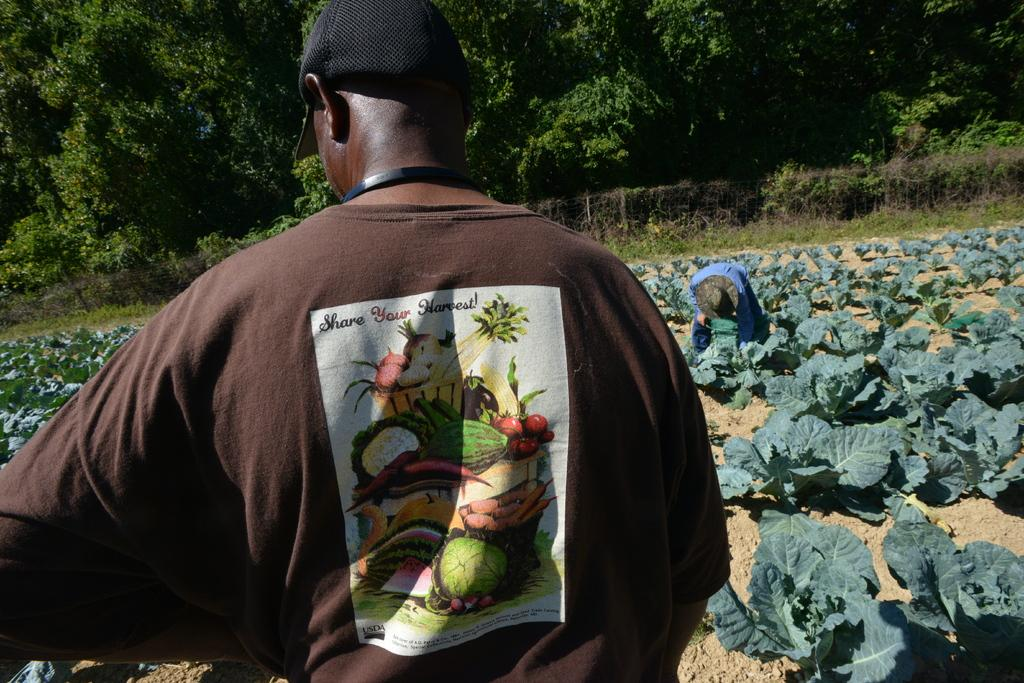What is the person in the image wearing on their upper body? The person in the image is wearing a brown T-shirt. Can you describe the position of the other person in the image? There is another person in front of the person wearing the brown T-shirt. What is blocking the view of the person wearing the brown T-shirt? Plants are in front of the person wearing the brown T-shirt. What can be seen in the distance in the image? There are trees in the background of the image. What type of vessel is being used to hold the glue in the image? There is no vessel or glue present in the image. 